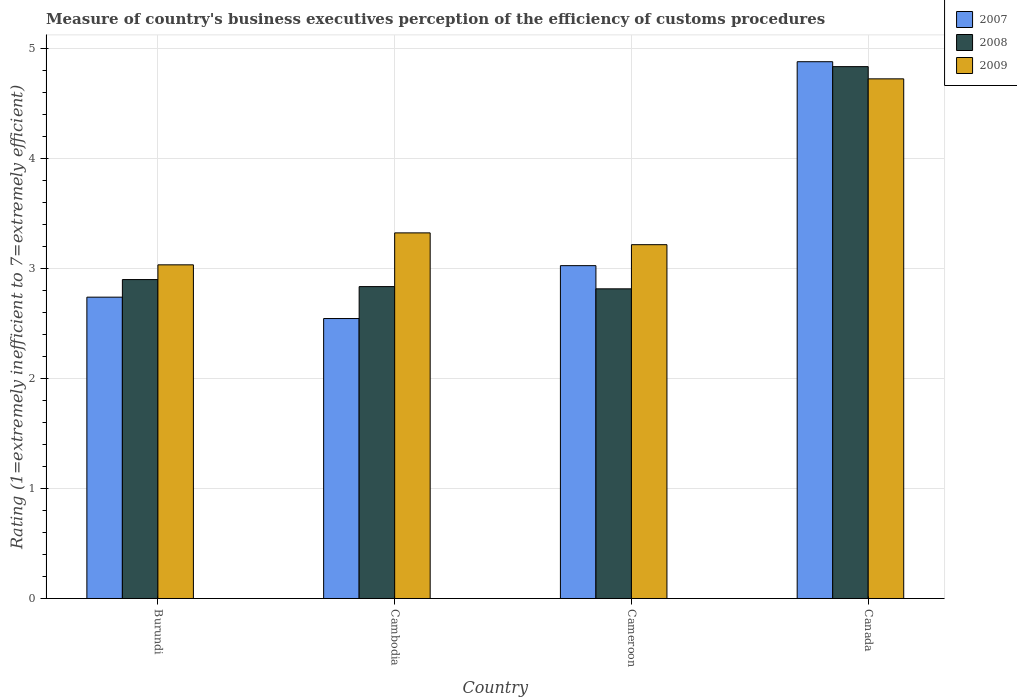Are the number of bars on each tick of the X-axis equal?
Provide a succinct answer. Yes. How many bars are there on the 3rd tick from the left?
Your response must be concise. 3. How many bars are there on the 3rd tick from the right?
Your response must be concise. 3. What is the label of the 4th group of bars from the left?
Your answer should be compact. Canada. What is the rating of the efficiency of customs procedure in 2009 in Cameroon?
Give a very brief answer. 3.22. Across all countries, what is the maximum rating of the efficiency of customs procedure in 2007?
Ensure brevity in your answer.  4.88. Across all countries, what is the minimum rating of the efficiency of customs procedure in 2009?
Keep it short and to the point. 3.03. In which country was the rating of the efficiency of customs procedure in 2009 maximum?
Make the answer very short. Canada. In which country was the rating of the efficiency of customs procedure in 2008 minimum?
Offer a terse response. Cameroon. What is the total rating of the efficiency of customs procedure in 2009 in the graph?
Keep it short and to the point. 14.3. What is the difference between the rating of the efficiency of customs procedure in 2008 in Cambodia and that in Canada?
Your response must be concise. -2. What is the difference between the rating of the efficiency of customs procedure in 2007 in Burundi and the rating of the efficiency of customs procedure in 2009 in Cameroon?
Make the answer very short. -0.48. What is the average rating of the efficiency of customs procedure in 2009 per country?
Keep it short and to the point. 3.57. What is the difference between the rating of the efficiency of customs procedure of/in 2007 and rating of the efficiency of customs procedure of/in 2008 in Burundi?
Your answer should be very brief. -0.16. What is the ratio of the rating of the efficiency of customs procedure in 2008 in Burundi to that in Cambodia?
Provide a short and direct response. 1.02. Is the difference between the rating of the efficiency of customs procedure in 2007 in Cameroon and Canada greater than the difference between the rating of the efficiency of customs procedure in 2008 in Cameroon and Canada?
Offer a terse response. Yes. What is the difference between the highest and the second highest rating of the efficiency of customs procedure in 2007?
Provide a short and direct response. -0.29. What is the difference between the highest and the lowest rating of the efficiency of customs procedure in 2008?
Offer a very short reply. 2.02. In how many countries, is the rating of the efficiency of customs procedure in 2008 greater than the average rating of the efficiency of customs procedure in 2008 taken over all countries?
Provide a succinct answer. 1. Is the sum of the rating of the efficiency of customs procedure in 2007 in Burundi and Canada greater than the maximum rating of the efficiency of customs procedure in 2008 across all countries?
Your answer should be compact. Yes. What does the 2nd bar from the left in Burundi represents?
Provide a short and direct response. 2008. What does the 1st bar from the right in Cameroon represents?
Offer a terse response. 2009. Is it the case that in every country, the sum of the rating of the efficiency of customs procedure in 2007 and rating of the efficiency of customs procedure in 2008 is greater than the rating of the efficiency of customs procedure in 2009?
Keep it short and to the point. Yes. How many countries are there in the graph?
Give a very brief answer. 4. What is the difference between two consecutive major ticks on the Y-axis?
Your answer should be very brief. 1. Are the values on the major ticks of Y-axis written in scientific E-notation?
Provide a succinct answer. No. Does the graph contain any zero values?
Provide a short and direct response. No. Does the graph contain grids?
Offer a terse response. Yes. How are the legend labels stacked?
Keep it short and to the point. Vertical. What is the title of the graph?
Give a very brief answer. Measure of country's business executives perception of the efficiency of customs procedures. Does "1979" appear as one of the legend labels in the graph?
Ensure brevity in your answer.  No. What is the label or title of the X-axis?
Your response must be concise. Country. What is the label or title of the Y-axis?
Your response must be concise. Rating (1=extremely inefficient to 7=extremely efficient). What is the Rating (1=extremely inefficient to 7=extremely efficient) in 2007 in Burundi?
Make the answer very short. 2.74. What is the Rating (1=extremely inefficient to 7=extremely efficient) of 2008 in Burundi?
Keep it short and to the point. 2.9. What is the Rating (1=extremely inefficient to 7=extremely efficient) of 2009 in Burundi?
Your response must be concise. 3.03. What is the Rating (1=extremely inefficient to 7=extremely efficient) of 2007 in Cambodia?
Offer a very short reply. 2.55. What is the Rating (1=extremely inefficient to 7=extremely efficient) in 2008 in Cambodia?
Offer a terse response. 2.84. What is the Rating (1=extremely inefficient to 7=extremely efficient) of 2009 in Cambodia?
Ensure brevity in your answer.  3.32. What is the Rating (1=extremely inefficient to 7=extremely efficient) in 2007 in Cameroon?
Give a very brief answer. 3.03. What is the Rating (1=extremely inefficient to 7=extremely efficient) in 2008 in Cameroon?
Provide a short and direct response. 2.82. What is the Rating (1=extremely inefficient to 7=extremely efficient) in 2009 in Cameroon?
Provide a short and direct response. 3.22. What is the Rating (1=extremely inefficient to 7=extremely efficient) of 2007 in Canada?
Offer a very short reply. 4.88. What is the Rating (1=extremely inefficient to 7=extremely efficient) of 2008 in Canada?
Make the answer very short. 4.84. What is the Rating (1=extremely inefficient to 7=extremely efficient) in 2009 in Canada?
Offer a very short reply. 4.72. Across all countries, what is the maximum Rating (1=extremely inefficient to 7=extremely efficient) in 2007?
Keep it short and to the point. 4.88. Across all countries, what is the maximum Rating (1=extremely inefficient to 7=extremely efficient) in 2008?
Keep it short and to the point. 4.84. Across all countries, what is the maximum Rating (1=extremely inefficient to 7=extremely efficient) of 2009?
Offer a very short reply. 4.72. Across all countries, what is the minimum Rating (1=extremely inefficient to 7=extremely efficient) in 2007?
Your response must be concise. 2.55. Across all countries, what is the minimum Rating (1=extremely inefficient to 7=extremely efficient) of 2008?
Give a very brief answer. 2.82. Across all countries, what is the minimum Rating (1=extremely inefficient to 7=extremely efficient) of 2009?
Your answer should be compact. 3.03. What is the total Rating (1=extremely inefficient to 7=extremely efficient) in 2007 in the graph?
Keep it short and to the point. 13.19. What is the total Rating (1=extremely inefficient to 7=extremely efficient) in 2008 in the graph?
Keep it short and to the point. 13.39. What is the total Rating (1=extremely inefficient to 7=extremely efficient) of 2009 in the graph?
Offer a very short reply. 14.3. What is the difference between the Rating (1=extremely inefficient to 7=extremely efficient) of 2007 in Burundi and that in Cambodia?
Keep it short and to the point. 0.19. What is the difference between the Rating (1=extremely inefficient to 7=extremely efficient) of 2008 in Burundi and that in Cambodia?
Give a very brief answer. 0.06. What is the difference between the Rating (1=extremely inefficient to 7=extremely efficient) of 2009 in Burundi and that in Cambodia?
Your answer should be very brief. -0.29. What is the difference between the Rating (1=extremely inefficient to 7=extremely efficient) in 2007 in Burundi and that in Cameroon?
Make the answer very short. -0.29. What is the difference between the Rating (1=extremely inefficient to 7=extremely efficient) of 2008 in Burundi and that in Cameroon?
Your answer should be compact. 0.08. What is the difference between the Rating (1=extremely inefficient to 7=extremely efficient) of 2009 in Burundi and that in Cameroon?
Provide a succinct answer. -0.18. What is the difference between the Rating (1=extremely inefficient to 7=extremely efficient) in 2007 in Burundi and that in Canada?
Your answer should be very brief. -2.14. What is the difference between the Rating (1=extremely inefficient to 7=extremely efficient) of 2008 in Burundi and that in Canada?
Your answer should be very brief. -1.94. What is the difference between the Rating (1=extremely inefficient to 7=extremely efficient) in 2009 in Burundi and that in Canada?
Make the answer very short. -1.69. What is the difference between the Rating (1=extremely inefficient to 7=extremely efficient) in 2007 in Cambodia and that in Cameroon?
Give a very brief answer. -0.48. What is the difference between the Rating (1=extremely inefficient to 7=extremely efficient) in 2008 in Cambodia and that in Cameroon?
Your answer should be compact. 0.02. What is the difference between the Rating (1=extremely inefficient to 7=extremely efficient) of 2009 in Cambodia and that in Cameroon?
Provide a short and direct response. 0.11. What is the difference between the Rating (1=extremely inefficient to 7=extremely efficient) of 2007 in Cambodia and that in Canada?
Give a very brief answer. -2.34. What is the difference between the Rating (1=extremely inefficient to 7=extremely efficient) in 2008 in Cambodia and that in Canada?
Give a very brief answer. -2. What is the difference between the Rating (1=extremely inefficient to 7=extremely efficient) of 2009 in Cambodia and that in Canada?
Provide a succinct answer. -1.4. What is the difference between the Rating (1=extremely inefficient to 7=extremely efficient) in 2007 in Cameroon and that in Canada?
Your answer should be very brief. -1.85. What is the difference between the Rating (1=extremely inefficient to 7=extremely efficient) in 2008 in Cameroon and that in Canada?
Your answer should be very brief. -2.02. What is the difference between the Rating (1=extremely inefficient to 7=extremely efficient) of 2009 in Cameroon and that in Canada?
Ensure brevity in your answer.  -1.51. What is the difference between the Rating (1=extremely inefficient to 7=extremely efficient) in 2007 in Burundi and the Rating (1=extremely inefficient to 7=extremely efficient) in 2008 in Cambodia?
Keep it short and to the point. -0.1. What is the difference between the Rating (1=extremely inefficient to 7=extremely efficient) of 2007 in Burundi and the Rating (1=extremely inefficient to 7=extremely efficient) of 2009 in Cambodia?
Ensure brevity in your answer.  -0.58. What is the difference between the Rating (1=extremely inefficient to 7=extremely efficient) of 2008 in Burundi and the Rating (1=extremely inefficient to 7=extremely efficient) of 2009 in Cambodia?
Offer a very short reply. -0.42. What is the difference between the Rating (1=extremely inefficient to 7=extremely efficient) in 2007 in Burundi and the Rating (1=extremely inefficient to 7=extremely efficient) in 2008 in Cameroon?
Ensure brevity in your answer.  -0.08. What is the difference between the Rating (1=extremely inefficient to 7=extremely efficient) in 2007 in Burundi and the Rating (1=extremely inefficient to 7=extremely efficient) in 2009 in Cameroon?
Ensure brevity in your answer.  -0.48. What is the difference between the Rating (1=extremely inefficient to 7=extremely efficient) of 2008 in Burundi and the Rating (1=extremely inefficient to 7=extremely efficient) of 2009 in Cameroon?
Your answer should be very brief. -0.32. What is the difference between the Rating (1=extremely inefficient to 7=extremely efficient) of 2007 in Burundi and the Rating (1=extremely inefficient to 7=extremely efficient) of 2008 in Canada?
Make the answer very short. -2.1. What is the difference between the Rating (1=extremely inefficient to 7=extremely efficient) of 2007 in Burundi and the Rating (1=extremely inefficient to 7=extremely efficient) of 2009 in Canada?
Provide a short and direct response. -1.99. What is the difference between the Rating (1=extremely inefficient to 7=extremely efficient) of 2008 in Burundi and the Rating (1=extremely inefficient to 7=extremely efficient) of 2009 in Canada?
Make the answer very short. -1.83. What is the difference between the Rating (1=extremely inefficient to 7=extremely efficient) in 2007 in Cambodia and the Rating (1=extremely inefficient to 7=extremely efficient) in 2008 in Cameroon?
Offer a terse response. -0.27. What is the difference between the Rating (1=extremely inefficient to 7=extremely efficient) of 2007 in Cambodia and the Rating (1=extremely inefficient to 7=extremely efficient) of 2009 in Cameroon?
Keep it short and to the point. -0.67. What is the difference between the Rating (1=extremely inefficient to 7=extremely efficient) in 2008 in Cambodia and the Rating (1=extremely inefficient to 7=extremely efficient) in 2009 in Cameroon?
Provide a succinct answer. -0.38. What is the difference between the Rating (1=extremely inefficient to 7=extremely efficient) in 2007 in Cambodia and the Rating (1=extremely inefficient to 7=extremely efficient) in 2008 in Canada?
Your answer should be compact. -2.29. What is the difference between the Rating (1=extremely inefficient to 7=extremely efficient) in 2007 in Cambodia and the Rating (1=extremely inefficient to 7=extremely efficient) in 2009 in Canada?
Provide a succinct answer. -2.18. What is the difference between the Rating (1=extremely inefficient to 7=extremely efficient) of 2008 in Cambodia and the Rating (1=extremely inefficient to 7=extremely efficient) of 2009 in Canada?
Offer a very short reply. -1.89. What is the difference between the Rating (1=extremely inefficient to 7=extremely efficient) of 2007 in Cameroon and the Rating (1=extremely inefficient to 7=extremely efficient) of 2008 in Canada?
Keep it short and to the point. -1.81. What is the difference between the Rating (1=extremely inefficient to 7=extremely efficient) in 2007 in Cameroon and the Rating (1=extremely inefficient to 7=extremely efficient) in 2009 in Canada?
Offer a very short reply. -1.7. What is the difference between the Rating (1=extremely inefficient to 7=extremely efficient) in 2008 in Cameroon and the Rating (1=extremely inefficient to 7=extremely efficient) in 2009 in Canada?
Keep it short and to the point. -1.91. What is the average Rating (1=extremely inefficient to 7=extremely efficient) of 2007 per country?
Make the answer very short. 3.3. What is the average Rating (1=extremely inefficient to 7=extremely efficient) of 2008 per country?
Keep it short and to the point. 3.35. What is the average Rating (1=extremely inefficient to 7=extremely efficient) in 2009 per country?
Ensure brevity in your answer.  3.57. What is the difference between the Rating (1=extremely inefficient to 7=extremely efficient) in 2007 and Rating (1=extremely inefficient to 7=extremely efficient) in 2008 in Burundi?
Ensure brevity in your answer.  -0.16. What is the difference between the Rating (1=extremely inefficient to 7=extremely efficient) in 2007 and Rating (1=extremely inefficient to 7=extremely efficient) in 2009 in Burundi?
Your answer should be very brief. -0.29. What is the difference between the Rating (1=extremely inefficient to 7=extremely efficient) in 2008 and Rating (1=extremely inefficient to 7=extremely efficient) in 2009 in Burundi?
Offer a terse response. -0.13. What is the difference between the Rating (1=extremely inefficient to 7=extremely efficient) of 2007 and Rating (1=extremely inefficient to 7=extremely efficient) of 2008 in Cambodia?
Provide a short and direct response. -0.29. What is the difference between the Rating (1=extremely inefficient to 7=extremely efficient) of 2007 and Rating (1=extremely inefficient to 7=extremely efficient) of 2009 in Cambodia?
Make the answer very short. -0.78. What is the difference between the Rating (1=extremely inefficient to 7=extremely efficient) in 2008 and Rating (1=extremely inefficient to 7=extremely efficient) in 2009 in Cambodia?
Your answer should be very brief. -0.49. What is the difference between the Rating (1=extremely inefficient to 7=extremely efficient) in 2007 and Rating (1=extremely inefficient to 7=extremely efficient) in 2008 in Cameroon?
Your response must be concise. 0.21. What is the difference between the Rating (1=extremely inefficient to 7=extremely efficient) of 2007 and Rating (1=extremely inefficient to 7=extremely efficient) of 2009 in Cameroon?
Keep it short and to the point. -0.19. What is the difference between the Rating (1=extremely inefficient to 7=extremely efficient) of 2008 and Rating (1=extremely inefficient to 7=extremely efficient) of 2009 in Cameroon?
Offer a terse response. -0.4. What is the difference between the Rating (1=extremely inefficient to 7=extremely efficient) in 2007 and Rating (1=extremely inefficient to 7=extremely efficient) in 2008 in Canada?
Your answer should be compact. 0.04. What is the difference between the Rating (1=extremely inefficient to 7=extremely efficient) in 2007 and Rating (1=extremely inefficient to 7=extremely efficient) in 2009 in Canada?
Keep it short and to the point. 0.16. What is the ratio of the Rating (1=extremely inefficient to 7=extremely efficient) in 2007 in Burundi to that in Cambodia?
Your response must be concise. 1.08. What is the ratio of the Rating (1=extremely inefficient to 7=extremely efficient) in 2008 in Burundi to that in Cambodia?
Offer a very short reply. 1.02. What is the ratio of the Rating (1=extremely inefficient to 7=extremely efficient) of 2009 in Burundi to that in Cambodia?
Your answer should be compact. 0.91. What is the ratio of the Rating (1=extremely inefficient to 7=extremely efficient) in 2007 in Burundi to that in Cameroon?
Ensure brevity in your answer.  0.91. What is the ratio of the Rating (1=extremely inefficient to 7=extremely efficient) in 2008 in Burundi to that in Cameroon?
Give a very brief answer. 1.03. What is the ratio of the Rating (1=extremely inefficient to 7=extremely efficient) in 2009 in Burundi to that in Cameroon?
Provide a succinct answer. 0.94. What is the ratio of the Rating (1=extremely inefficient to 7=extremely efficient) in 2007 in Burundi to that in Canada?
Provide a short and direct response. 0.56. What is the ratio of the Rating (1=extremely inefficient to 7=extremely efficient) of 2008 in Burundi to that in Canada?
Ensure brevity in your answer.  0.6. What is the ratio of the Rating (1=extremely inefficient to 7=extremely efficient) in 2009 in Burundi to that in Canada?
Ensure brevity in your answer.  0.64. What is the ratio of the Rating (1=extremely inefficient to 7=extremely efficient) in 2007 in Cambodia to that in Cameroon?
Keep it short and to the point. 0.84. What is the ratio of the Rating (1=extremely inefficient to 7=extremely efficient) in 2009 in Cambodia to that in Cameroon?
Keep it short and to the point. 1.03. What is the ratio of the Rating (1=extremely inefficient to 7=extremely efficient) in 2007 in Cambodia to that in Canada?
Provide a short and direct response. 0.52. What is the ratio of the Rating (1=extremely inefficient to 7=extremely efficient) of 2008 in Cambodia to that in Canada?
Keep it short and to the point. 0.59. What is the ratio of the Rating (1=extremely inefficient to 7=extremely efficient) of 2009 in Cambodia to that in Canada?
Ensure brevity in your answer.  0.7. What is the ratio of the Rating (1=extremely inefficient to 7=extremely efficient) in 2007 in Cameroon to that in Canada?
Offer a terse response. 0.62. What is the ratio of the Rating (1=extremely inefficient to 7=extremely efficient) of 2008 in Cameroon to that in Canada?
Your response must be concise. 0.58. What is the ratio of the Rating (1=extremely inefficient to 7=extremely efficient) in 2009 in Cameroon to that in Canada?
Your answer should be compact. 0.68. What is the difference between the highest and the second highest Rating (1=extremely inefficient to 7=extremely efficient) of 2007?
Ensure brevity in your answer.  1.85. What is the difference between the highest and the second highest Rating (1=extremely inefficient to 7=extremely efficient) in 2008?
Give a very brief answer. 1.94. What is the difference between the highest and the second highest Rating (1=extremely inefficient to 7=extremely efficient) in 2009?
Your answer should be compact. 1.4. What is the difference between the highest and the lowest Rating (1=extremely inefficient to 7=extremely efficient) in 2007?
Give a very brief answer. 2.34. What is the difference between the highest and the lowest Rating (1=extremely inefficient to 7=extremely efficient) in 2008?
Your answer should be compact. 2.02. What is the difference between the highest and the lowest Rating (1=extremely inefficient to 7=extremely efficient) in 2009?
Ensure brevity in your answer.  1.69. 